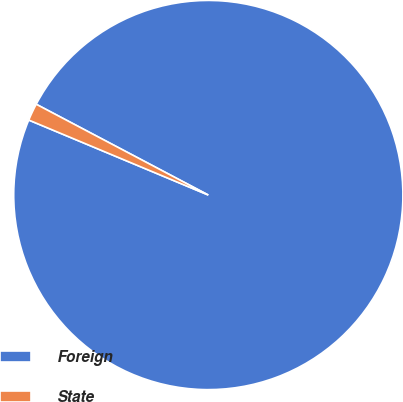<chart> <loc_0><loc_0><loc_500><loc_500><pie_chart><fcel>Foreign<fcel>State<nl><fcel>98.57%<fcel>1.43%<nl></chart> 